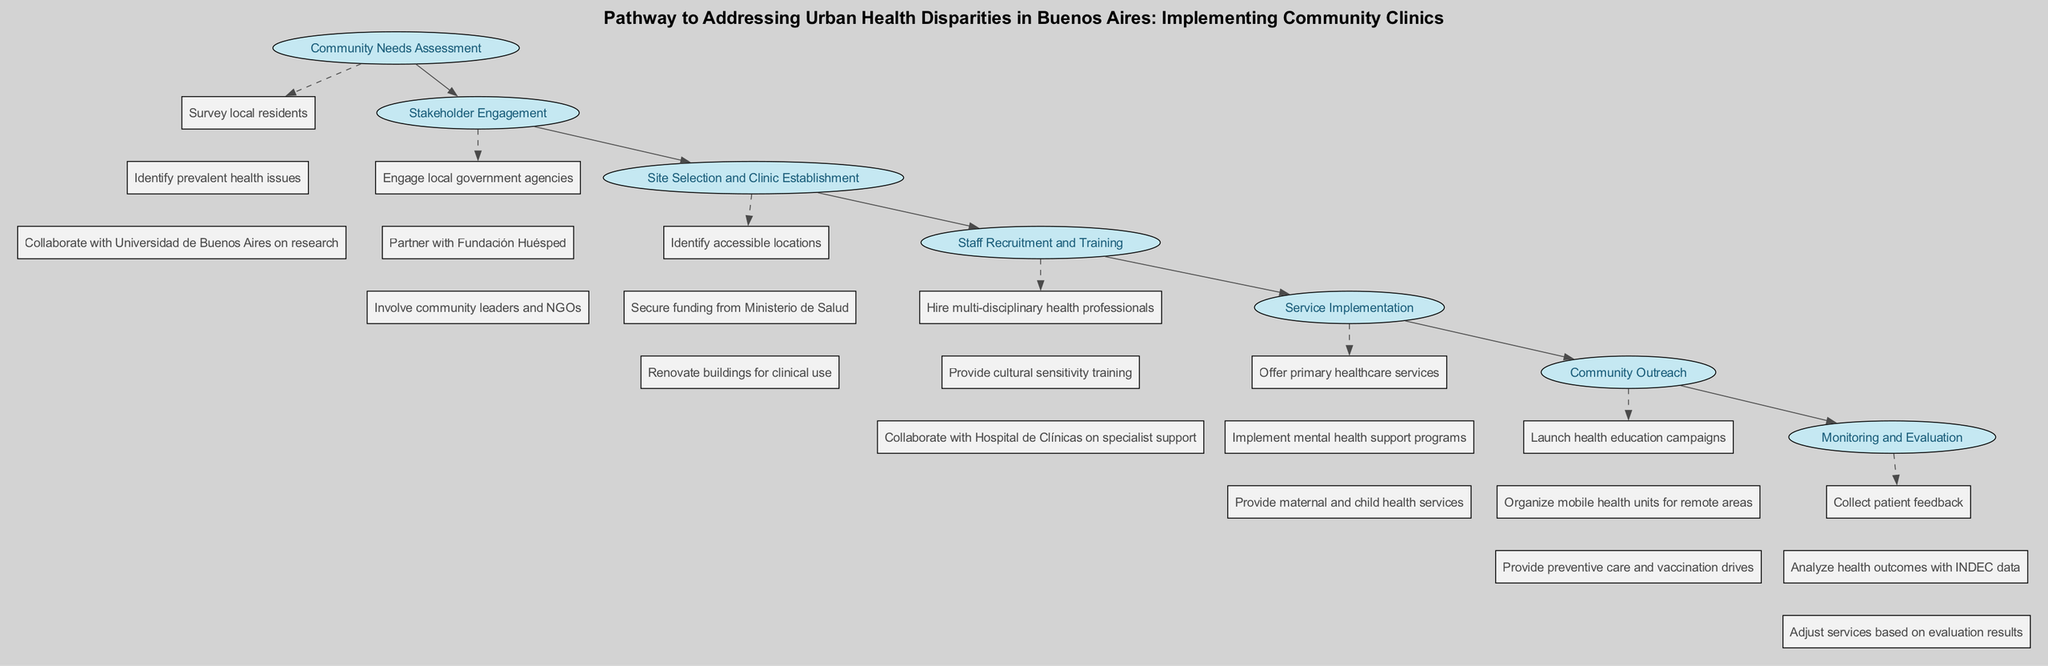What is the first step in the pathway? The first step listed in the diagram is "Community Needs Assessment." It appears at the top of the flow indicating the starting point of the pathway.
Answer: Community Needs Assessment How many actions are listed under "Stakeholder Engagement"? In the diagram, "Stakeholder Engagement" has three actions listed. By counting these actions, we can confirm this number.
Answer: 3 Which organization is involved in the "Staff Recruitment and Training" step? "Hospital de Clínicas" is specifically mentioned as a collaborator for specialist support in this step, indicating its involvement.
Answer: Hospital de Clínicas What type of services are offered in the fifth step? Under "Service Implementation," several services are provided, specifically primary healthcare, mental health support, and maternal and child health services. These are enumerated in the actions of this step.
Answer: primary healthcare services, mental health support programs, maternal and child health services What connects "Monitoring and Evaluation" to the previous step? The connection is established by a direct edge leading from "Community Outreach" to "Monitoring and Evaluation," indicating the flow from one step to the other in the pathway.
Answer: Community Outreach What is the main purpose of the "Community Needs Assessment"? The main focus is to survey local residents, identify prevalent health issues, and collaborate with Universidad de Buenos Aires, thus establishing community health issues before moving forward in the pathway.
Answer: Survey local residents Which phase follows "Site Selection and Clinic Establishment"? The flow of the diagram indicates that "Staff Recruitment and Training" directly follows "Site Selection and Clinic Establishment" as the next step in the pathway.
Answer: Staff Recruitment and Training What element is emphasized during "Service Implementation"? The emphasis is on offering primary healthcare services, seen in the first action of this step. It signifies the central role of primary healthcare in the overall strategy of addressing health disparities.
Answer: primary healthcare services 